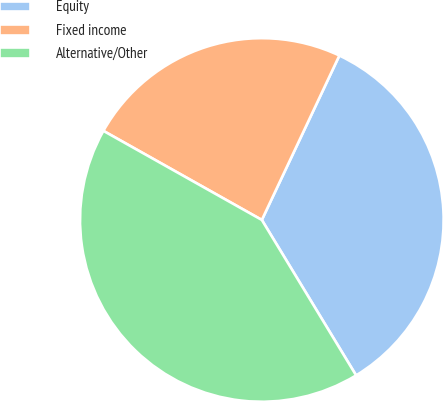Convert chart to OTSL. <chart><loc_0><loc_0><loc_500><loc_500><pie_chart><fcel>Equity<fcel>Fixed income<fcel>Alternative/Other<nl><fcel>34.31%<fcel>23.86%<fcel>41.83%<nl></chart> 